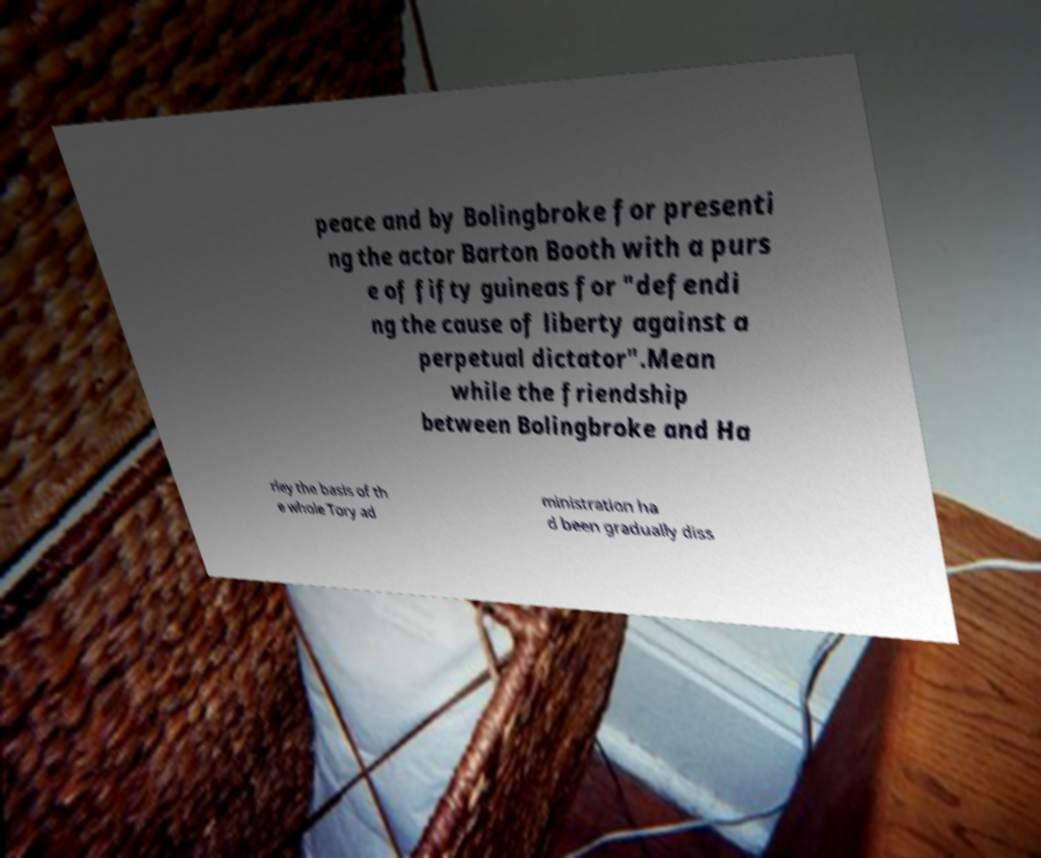I need the written content from this picture converted into text. Can you do that? peace and by Bolingbroke for presenti ng the actor Barton Booth with a purs e of fifty guineas for "defendi ng the cause of liberty against a perpetual dictator".Mean while the friendship between Bolingbroke and Ha rley the basis of th e whole Tory ad ministration ha d been gradually diss 